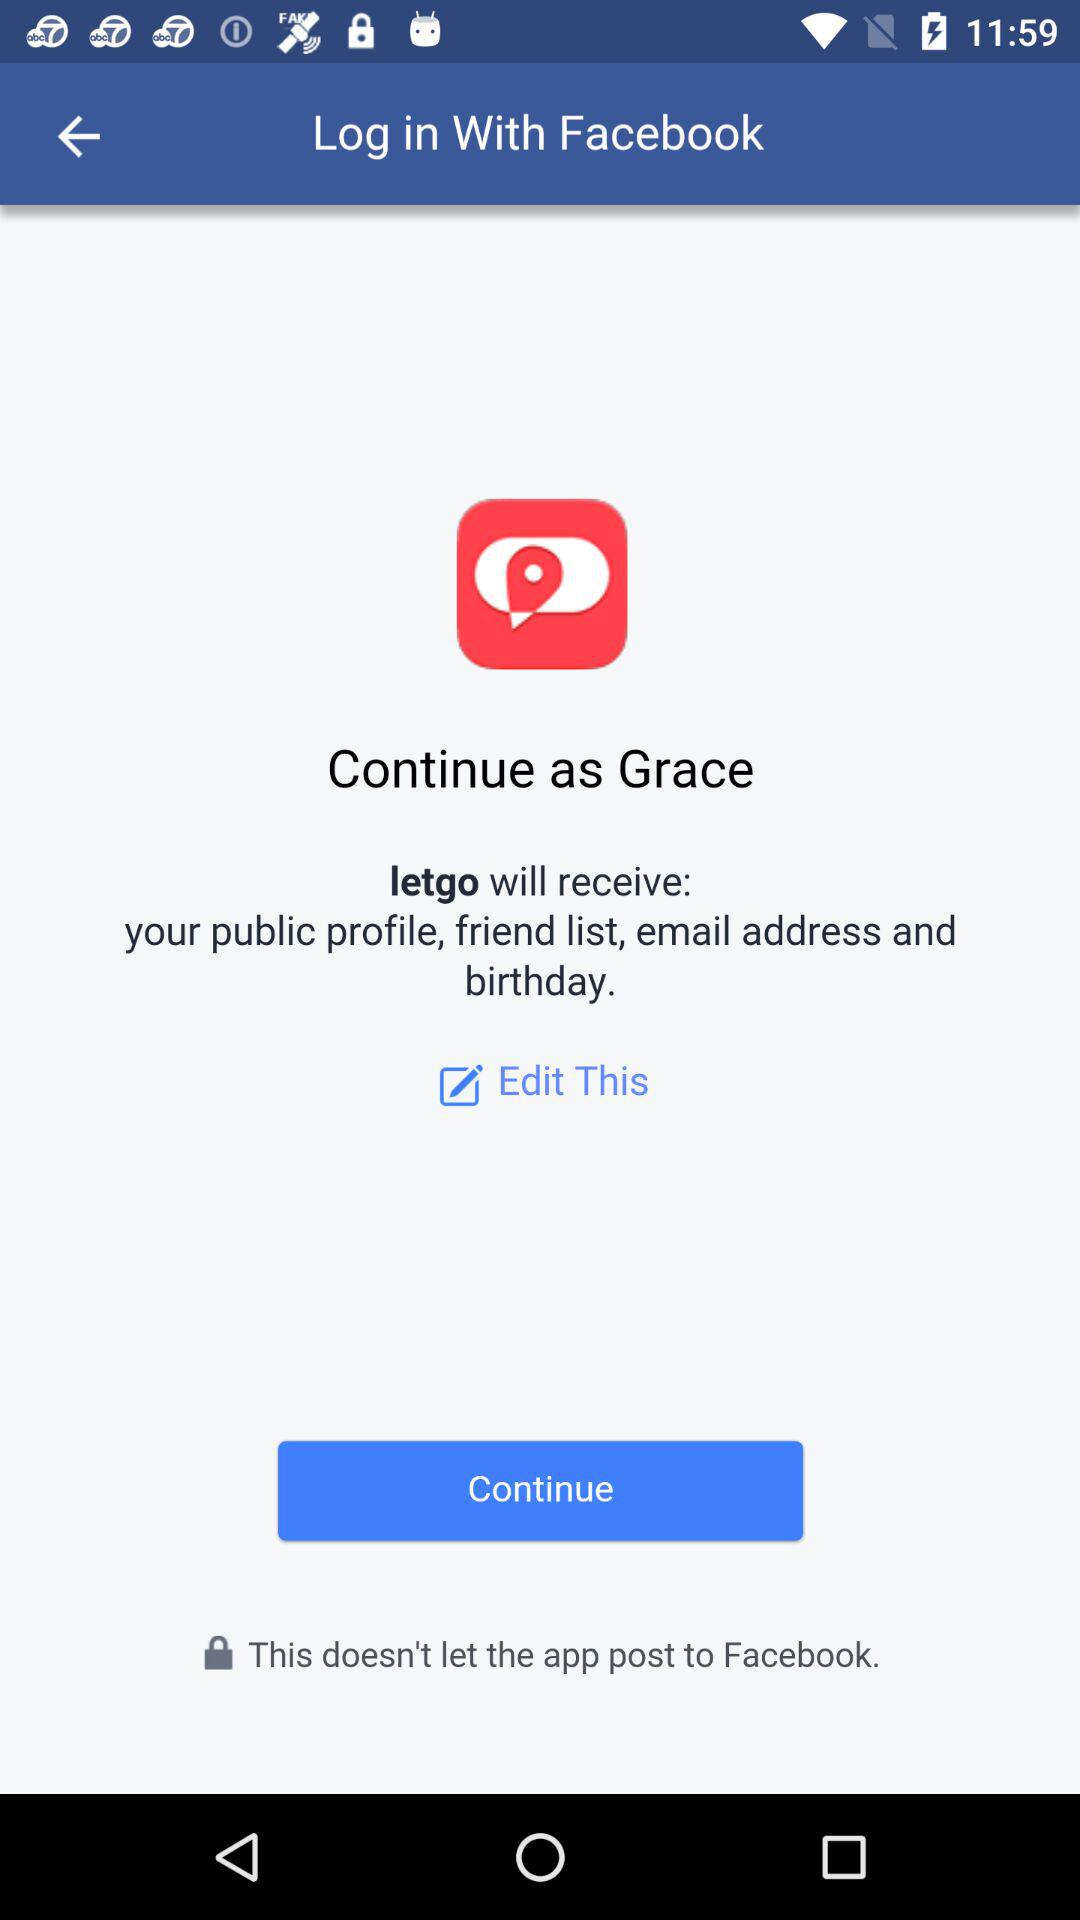What is the name of the application that can be used to log in? The name of the application that can be used to log in is "Facebook". 